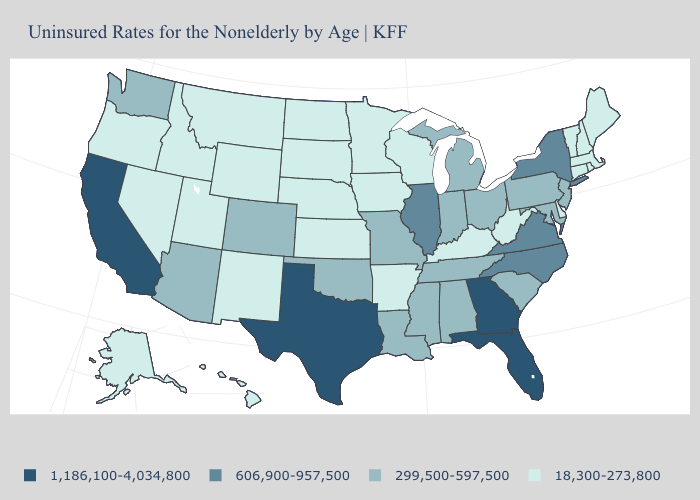Which states hav the highest value in the West?
Quick response, please. California. Name the states that have a value in the range 18,300-273,800?
Write a very short answer. Alaska, Arkansas, Connecticut, Delaware, Hawaii, Idaho, Iowa, Kansas, Kentucky, Maine, Massachusetts, Minnesota, Montana, Nebraska, Nevada, New Hampshire, New Mexico, North Dakota, Oregon, Rhode Island, South Dakota, Utah, Vermont, West Virginia, Wisconsin, Wyoming. Which states hav the highest value in the West?
Short answer required. California. Among the states that border Iowa , which have the highest value?
Quick response, please. Illinois. What is the highest value in the South ?
Answer briefly. 1,186,100-4,034,800. Does the map have missing data?
Short answer required. No. What is the value of Vermont?
Short answer required. 18,300-273,800. How many symbols are there in the legend?
Quick response, please. 4. What is the highest value in the USA?
Answer briefly. 1,186,100-4,034,800. Name the states that have a value in the range 1,186,100-4,034,800?
Give a very brief answer. California, Florida, Georgia, Texas. Name the states that have a value in the range 1,186,100-4,034,800?
Short answer required. California, Florida, Georgia, Texas. Among the states that border Missouri , does Kansas have the highest value?
Give a very brief answer. No. Name the states that have a value in the range 18,300-273,800?
Answer briefly. Alaska, Arkansas, Connecticut, Delaware, Hawaii, Idaho, Iowa, Kansas, Kentucky, Maine, Massachusetts, Minnesota, Montana, Nebraska, Nevada, New Hampshire, New Mexico, North Dakota, Oregon, Rhode Island, South Dakota, Utah, Vermont, West Virginia, Wisconsin, Wyoming. 